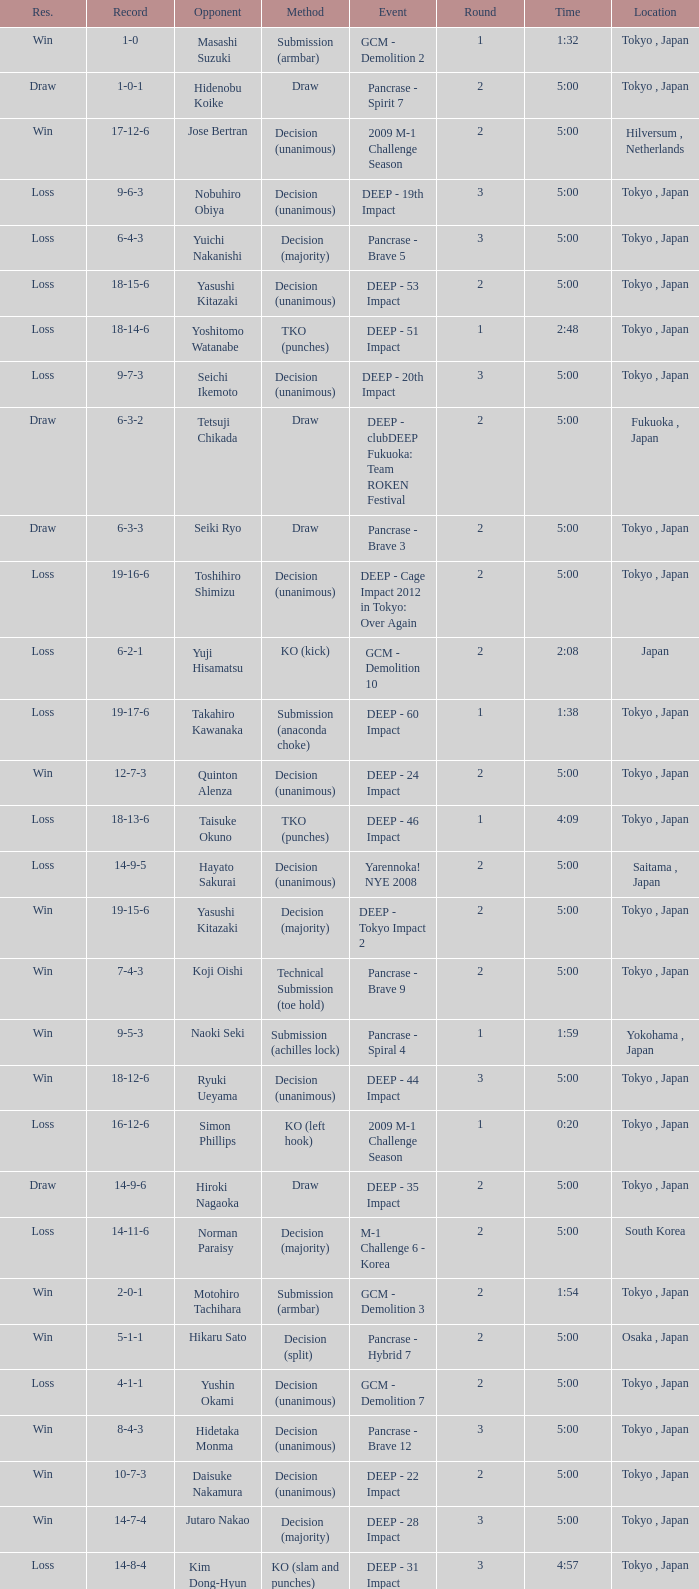What is the location when the record is 5-1-1? Osaka , Japan. 